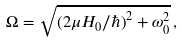<formula> <loc_0><loc_0><loc_500><loc_500>\Omega = \sqrt { ( 2 \mu H _ { 0 } / \hbar { ) } ^ { 2 } + \omega _ { 0 } ^ { 2 } } \, ,</formula> 